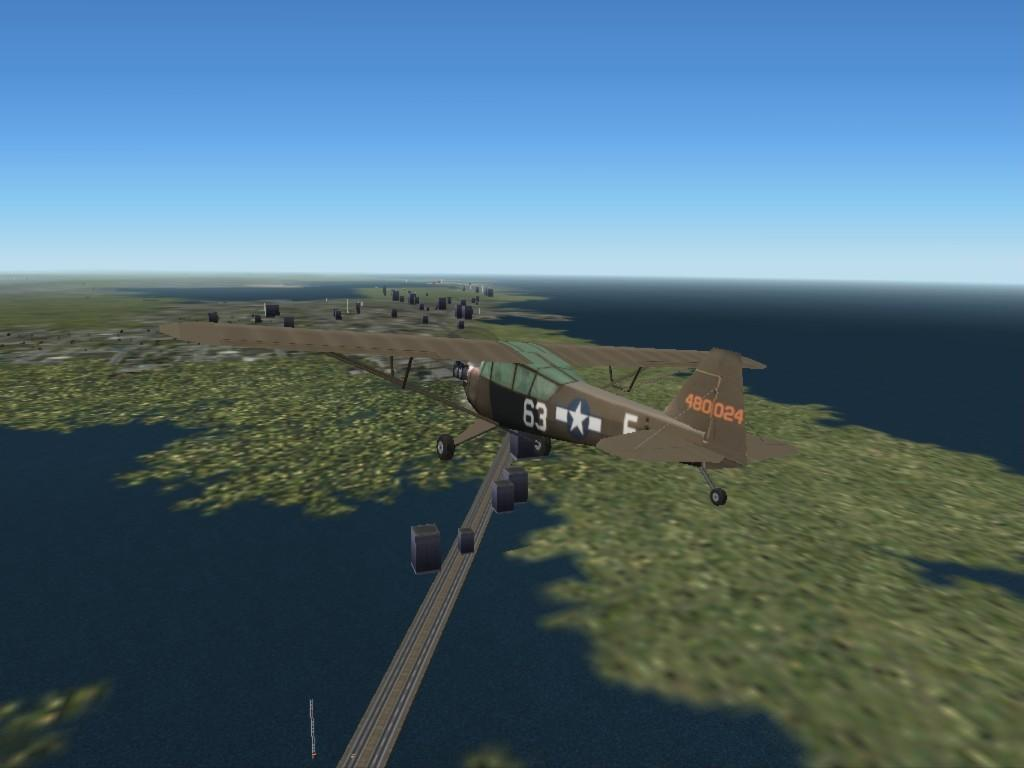Provide a one-sentence caption for the provided image. computer animation of plane number 63 and on tail it has 480024. 